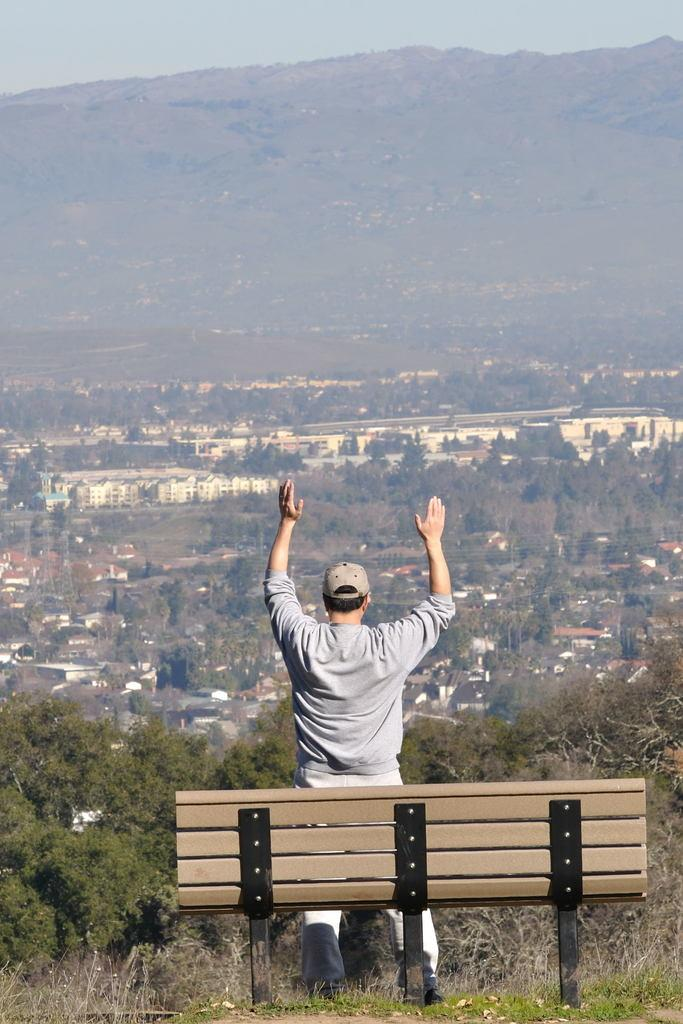What is the person in the image doing? The person is standing in front of a bench. What can be seen in the background of the image? The sky, mountains, trees, and buildings are visible in the background. Can you describe the natural elements in the background? The mountains and trees are natural elements in the background. What type of shirt is the person wearing in the image? The provided facts do not mention the person's shirt, so we cannot determine the type of shirt they are wearing. --- Facts: 1. There is a car in the image. 2. The car is red. 3. The car has four wheels. 4. There is a road in the image. 5. The road is paved. Absurd Topics: bird, ocean, dance Conversation: What is the main subject of the image? The main subject of the image is a car. What color is the car? The car is red. How many wheels does the car have? The car has four wheels. What type of surface is the car on? The car is on a road. Can you describe the road in the image? The road is paved. Reasoning: Let's think step by step in order to produce the conversation. We start by identifying the main subject in the image, which is the car. Then, we describe specific details about the car, such as its color and the number of wheels. Next, we mention the road and describe its surface. Each question is designed to elicit a specific detail about the image that is known from the provided facts provided. Absurd Question/Answer: Can you see any birds flying over the ocean in the image? There is no mention of birds or an ocean in the provided facts, so we cannot determine if they are present in the image. 